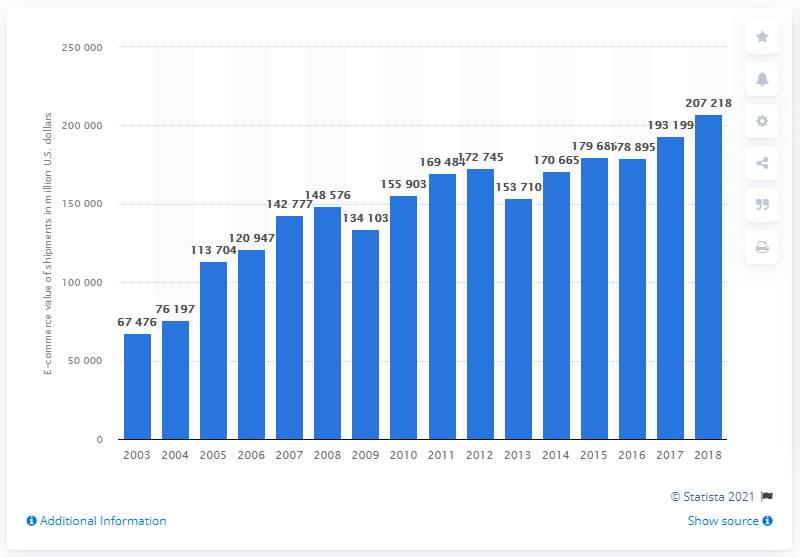Outline some significant characteristics in this image. In 2018, the value of B2B e-commerce shipments for computer and electronic products manufacturing in the United States was $207.218 billion. In the previous measured period, the B2B e-commerce value of computer and electronic products manufacturing shipments was 193,199. 